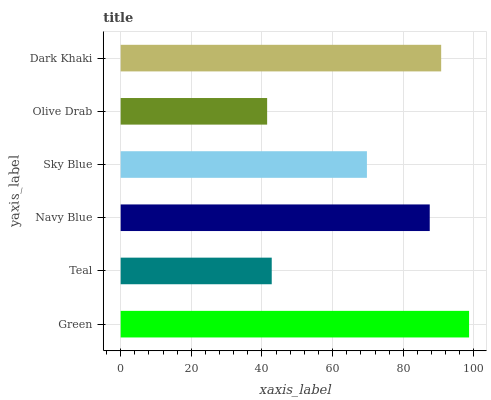Is Olive Drab the minimum?
Answer yes or no. Yes. Is Green the maximum?
Answer yes or no. Yes. Is Teal the minimum?
Answer yes or no. No. Is Teal the maximum?
Answer yes or no. No. Is Green greater than Teal?
Answer yes or no. Yes. Is Teal less than Green?
Answer yes or no. Yes. Is Teal greater than Green?
Answer yes or no. No. Is Green less than Teal?
Answer yes or no. No. Is Navy Blue the high median?
Answer yes or no. Yes. Is Sky Blue the low median?
Answer yes or no. Yes. Is Dark Khaki the high median?
Answer yes or no. No. Is Dark Khaki the low median?
Answer yes or no. No. 